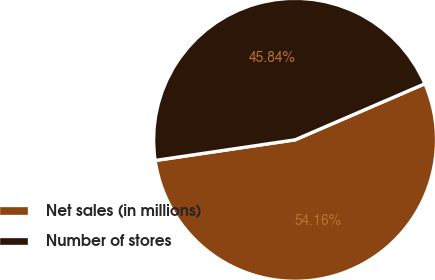Convert chart. <chart><loc_0><loc_0><loc_500><loc_500><pie_chart><fcel>Net sales (in millions)<fcel>Number of stores<nl><fcel>54.16%<fcel>45.84%<nl></chart> 